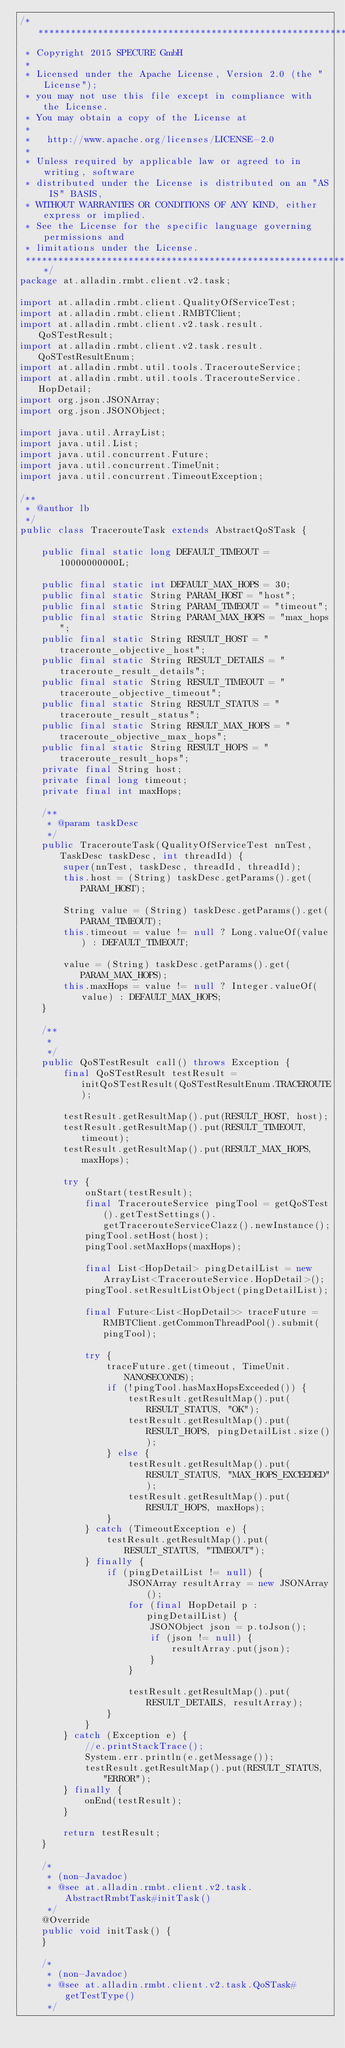Convert code to text. <code><loc_0><loc_0><loc_500><loc_500><_Java_>/*******************************************************************************
 * Copyright 2015 SPECURE GmbH
 *
 * Licensed under the Apache License, Version 2.0 (the "License");
 * you may not use this file except in compliance with the License.
 * You may obtain a copy of the License at
 *
 *   http://www.apache.org/licenses/LICENSE-2.0
 *
 * Unless required by applicable law or agreed to in writing, software
 * distributed under the License is distributed on an "AS IS" BASIS,
 * WITHOUT WARRANTIES OR CONDITIONS OF ANY KIND, either express or implied.
 * See the License for the specific language governing permissions and
 * limitations under the License.
 *******************************************************************************/
package at.alladin.rmbt.client.v2.task;

import at.alladin.rmbt.client.QualityOfServiceTest;
import at.alladin.rmbt.client.RMBTClient;
import at.alladin.rmbt.client.v2.task.result.QoSTestResult;
import at.alladin.rmbt.client.v2.task.result.QoSTestResultEnum;
import at.alladin.rmbt.util.tools.TracerouteService;
import at.alladin.rmbt.util.tools.TracerouteService.HopDetail;
import org.json.JSONArray;
import org.json.JSONObject;

import java.util.ArrayList;
import java.util.List;
import java.util.concurrent.Future;
import java.util.concurrent.TimeUnit;
import java.util.concurrent.TimeoutException;

/**
 * @author lb
 */
public class TracerouteTask extends AbstractQoSTask {

    public final static long DEFAULT_TIMEOUT = 10000000000L;

    public final static int DEFAULT_MAX_HOPS = 30;
    public final static String PARAM_HOST = "host";
    public final static String PARAM_TIMEOUT = "timeout";
    public final static String PARAM_MAX_HOPS = "max_hops";
    public final static String RESULT_HOST = "traceroute_objective_host";
    public final static String RESULT_DETAILS = "traceroute_result_details";
    public final static String RESULT_TIMEOUT = "traceroute_objective_timeout";
    public final static String RESULT_STATUS = "traceroute_result_status";
    public final static String RESULT_MAX_HOPS = "traceroute_objective_max_hops";
    public final static String RESULT_HOPS = "traceroute_result_hops";
    private final String host;
    private final long timeout;
    private final int maxHops;

    /**
     * @param taskDesc
     */
    public TracerouteTask(QualityOfServiceTest nnTest, TaskDesc taskDesc, int threadId) {
        super(nnTest, taskDesc, threadId, threadId);
        this.host = (String) taskDesc.getParams().get(PARAM_HOST);

        String value = (String) taskDesc.getParams().get(PARAM_TIMEOUT);
        this.timeout = value != null ? Long.valueOf(value) : DEFAULT_TIMEOUT;

        value = (String) taskDesc.getParams().get(PARAM_MAX_HOPS);
        this.maxHops = value != null ? Integer.valueOf(value) : DEFAULT_MAX_HOPS;
    }

    /**
     *
     */
    public QoSTestResult call() throws Exception {
        final QoSTestResult testResult = initQoSTestResult(QoSTestResultEnum.TRACEROUTE);

        testResult.getResultMap().put(RESULT_HOST, host);
        testResult.getResultMap().put(RESULT_TIMEOUT, timeout);
        testResult.getResultMap().put(RESULT_MAX_HOPS, maxHops);

        try {
            onStart(testResult);
            final TracerouteService pingTool = getQoSTest().getTestSettings().getTracerouteServiceClazz().newInstance();
            pingTool.setHost(host);
            pingTool.setMaxHops(maxHops);

            final List<HopDetail> pingDetailList = new ArrayList<TracerouteService.HopDetail>();
            pingTool.setResultListObject(pingDetailList);

            final Future<List<HopDetail>> traceFuture = RMBTClient.getCommonThreadPool().submit(pingTool);

            try {
                traceFuture.get(timeout, TimeUnit.NANOSECONDS);
                if (!pingTool.hasMaxHopsExceeded()) {
                    testResult.getResultMap().put(RESULT_STATUS, "OK");
                    testResult.getResultMap().put(RESULT_HOPS, pingDetailList.size());
                } else {
                    testResult.getResultMap().put(RESULT_STATUS, "MAX_HOPS_EXCEEDED");
                    testResult.getResultMap().put(RESULT_HOPS, maxHops);
                }
            } catch (TimeoutException e) {
                testResult.getResultMap().put(RESULT_STATUS, "TIMEOUT");
            } finally {
                if (pingDetailList != null) {
                    JSONArray resultArray = new JSONArray();
                    for (final HopDetail p : pingDetailList) {
                        JSONObject json = p.toJson();
                        if (json != null) {
                            resultArray.put(json);
                        }
                    }

                    testResult.getResultMap().put(RESULT_DETAILS, resultArray);
                }
            }
        } catch (Exception e) {
            //e.printStackTrace();
            System.err.println(e.getMessage());
            testResult.getResultMap().put(RESULT_STATUS, "ERROR");
        } finally {
            onEnd(testResult);
        }

        return testResult;
    }

    /*
     * (non-Javadoc)
     * @see at.alladin.rmbt.client.v2.task.AbstractRmbtTask#initTask()
     */
    @Override
    public void initTask() {
    }

    /*
     * (non-Javadoc)
     * @see at.alladin.rmbt.client.v2.task.QoSTask#getTestType()
     */</code> 